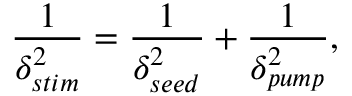<formula> <loc_0><loc_0><loc_500><loc_500>\frac { 1 } { \delta _ { s t i m } ^ { 2 } } = \frac { 1 } { \delta _ { s e e d } ^ { 2 } } + \frac { 1 } { \delta _ { p u m p } ^ { 2 } } ,</formula> 